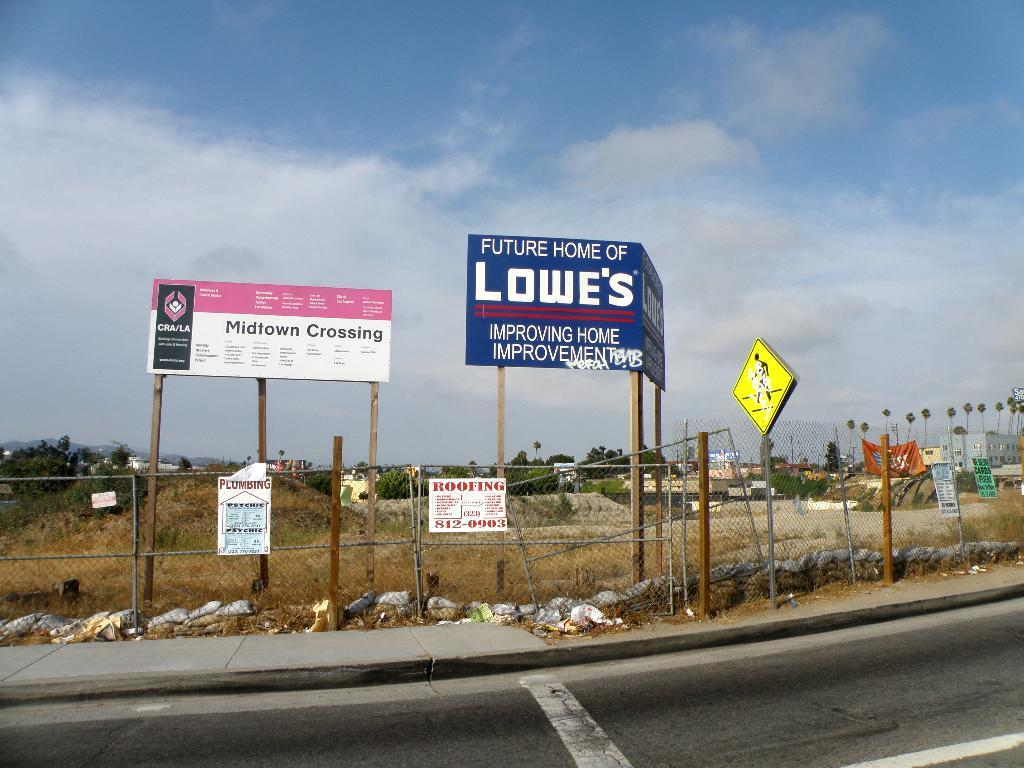What is located at the bottom of the image? There is a road at the bottom of the image. What type of vegetation can be seen on the right side of the image? There are trees on the right side of the image. What can be found in the background of the image? There are written text boards in the background of the image. What color is the zipper on the sock in the image? There is no zipper or sock present in the image. What type of day is depicted in the image? The image does not depict a specific day; it only shows a road, trees, and text boards. 